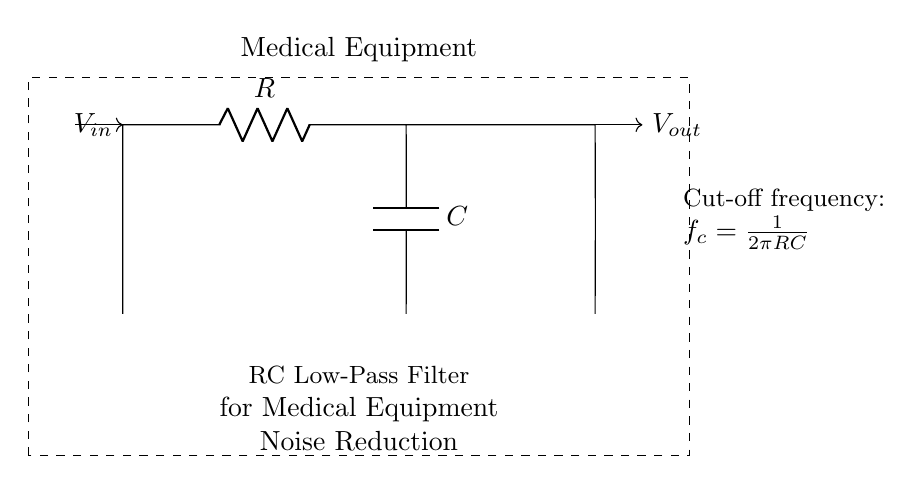What components are in this circuit? The circuit consists of a resistor and a capacitor. The resistor is labeled R and the capacitor is labeled C, both of which are key components in forming the low-pass filter.
Answer: Resistor and capacitor What is the output voltage labeled? The output voltage is labeled V out in the circuit diagram, indicating the voltage measured across the capacitor after filtering out higher frequency noise.
Answer: V out What does the term 'cut-off frequency' mean? The cut-off frequency, denoted by f c in the diagram, is the frequency at which the output voltage is reduced to 70.7% of the input voltage. It is a critical parameter for filtering noise.
Answer: Frequency at which output is reduced to 70.7% of input How is the cut-off frequency calculated? The cut-off frequency is calculated using the formula f c = 1/(2πRC). This relationship shows that the frequency is inversely proportional to both the resistor value and the capacitor value.
Answer: f c = 1/(2πRC) What is the function of this circuit? The function of the RC low-pass filter is to allow low-frequency signals to pass through while attenuating higher-frequency noise, making it particularly useful for medical equipment that requires noise reduction.
Answer: Noise reduction What occurs if the resistance value is increased? Increasing the resistance (R) will lower the cut-off frequency (f c), allowing even lower frequencies to pass through the filter while attenuating even higher frequencies more effectively.
Answer: Lowers cut-off frequency What is the relationship between the resistor and capacitor in terms of noise filtering? The resistor and capacitor work together to form a time constant (τ = RC), which determines how quickly the circuit responds to changes in input signals, therefore affecting the filtering capability regarding noise.
Answer: They determine time constant for filtering 